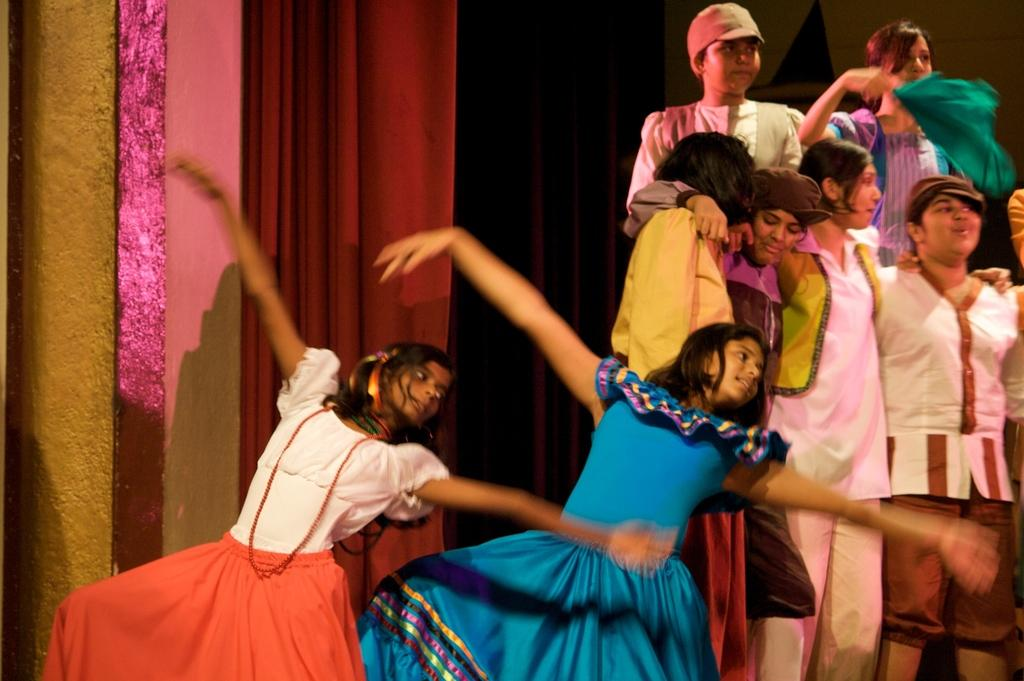How many girls are present in the image? There are two girls standing in the image. What else can be seen in the image besides the girls? There is a group of people standing in the image. What type of object is hanging in the image? There appears to be a curtain hanging in the image. What type of structure is visible in the image? There is a wall visible in the image. What type of thought is being expressed by the drawer in the image? There is no drawer present in the image, and therefore no thoughts can be attributed to it. 